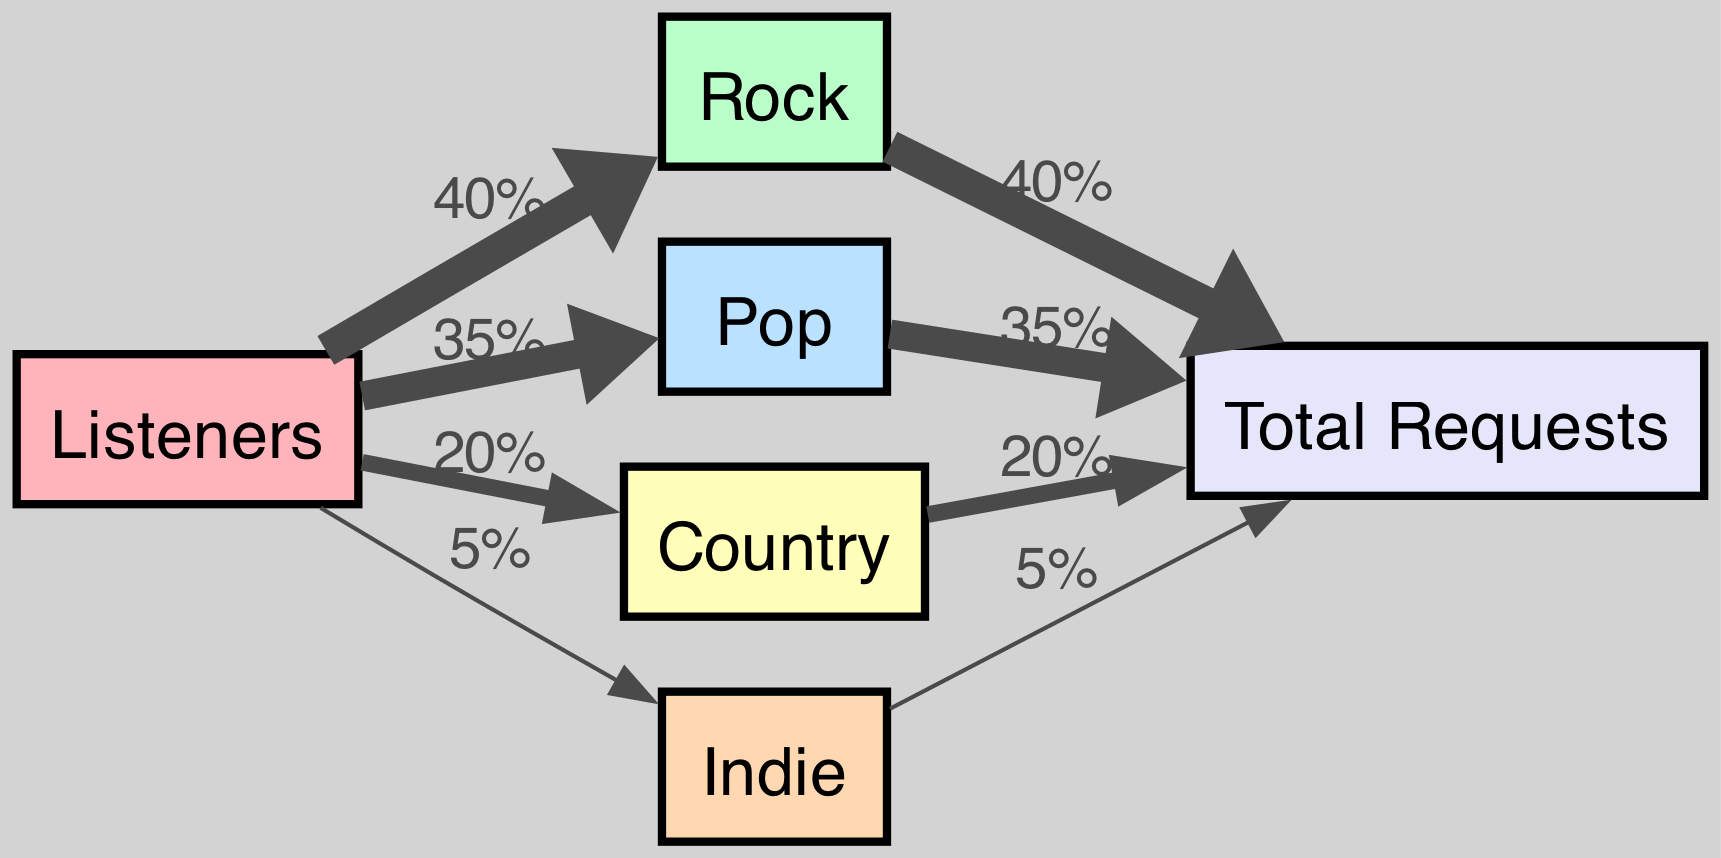What is the total percentage of requests for Rock tracks? The diagram shows a direct link from the "Listeners" node to the "Rock" node with a value of 40%. This indicates that 40% of the total requests were specifically for Rock tracks.
Answer: 40% Which genre received the least requests? The node "Indie" has a direct link from the "Listeners" node with a value of 5%. This shows that Indie tracks had the fewest requests among the listed genres.
Answer: Indie How many total nodes are present in the diagram? By counting each unique node in the diagram, we find that there are six nodes: Rock, Pop, Country, Indie, Listeners, and Requests, which totals to six nodes.
Answer: 6 What percentage of requests were for Pop tracks? There is a direct link from the "Listeners" node to the "Pop" node labeled with a value of 35%. This shows that 35% of the total requests were for Pop tracks.
Answer: 35% Which genre received more requests, Country or Indie? The "Country" node has a direct link labeled 20%, while the "Indie" node has a link labeled 5%. Comparing these values shows that Country received significantly more requests than Indie.
Answer: Country What percentage of the total requests do Rock and Pop combined represent? The Rock node shows 40% and the Pop node shows 35%. Adding these two percentages together (40% + 35%) gives a total of 75% for both Rock and Pop combined.
Answer: 75% How does the flow of requests for Country tracks compare to the total requests for all genres? Country tracks represent 20% of requests (indicated by the Country node), whereas the total percentage of all requests can be determined by summing the values for all genres: Rock (40%) + Pop (35%) + Country (20%) + Indie (5%) = 100%. Therefore, Country tracks account for 20% of the total requests, while the total is 100%.
Answer: 20% What is the relationship between the "Listeners" node and the "Total Requests" node? The "Listeners" node has direct connections to each genre, and these connections ultimately lead to the "Total Requests" node. This illustrates that the number of requests from the listeners contributes to the total count reflected in the "Requests" node.
Answer: Direct connection through requests What is the proportion of Indie requests to the total requests? The "Indie" node shows a value of 5%, and since the total is 100%, the proportion of Indie requests compared to the total is calculated directly as 5%.
Answer: 5% 